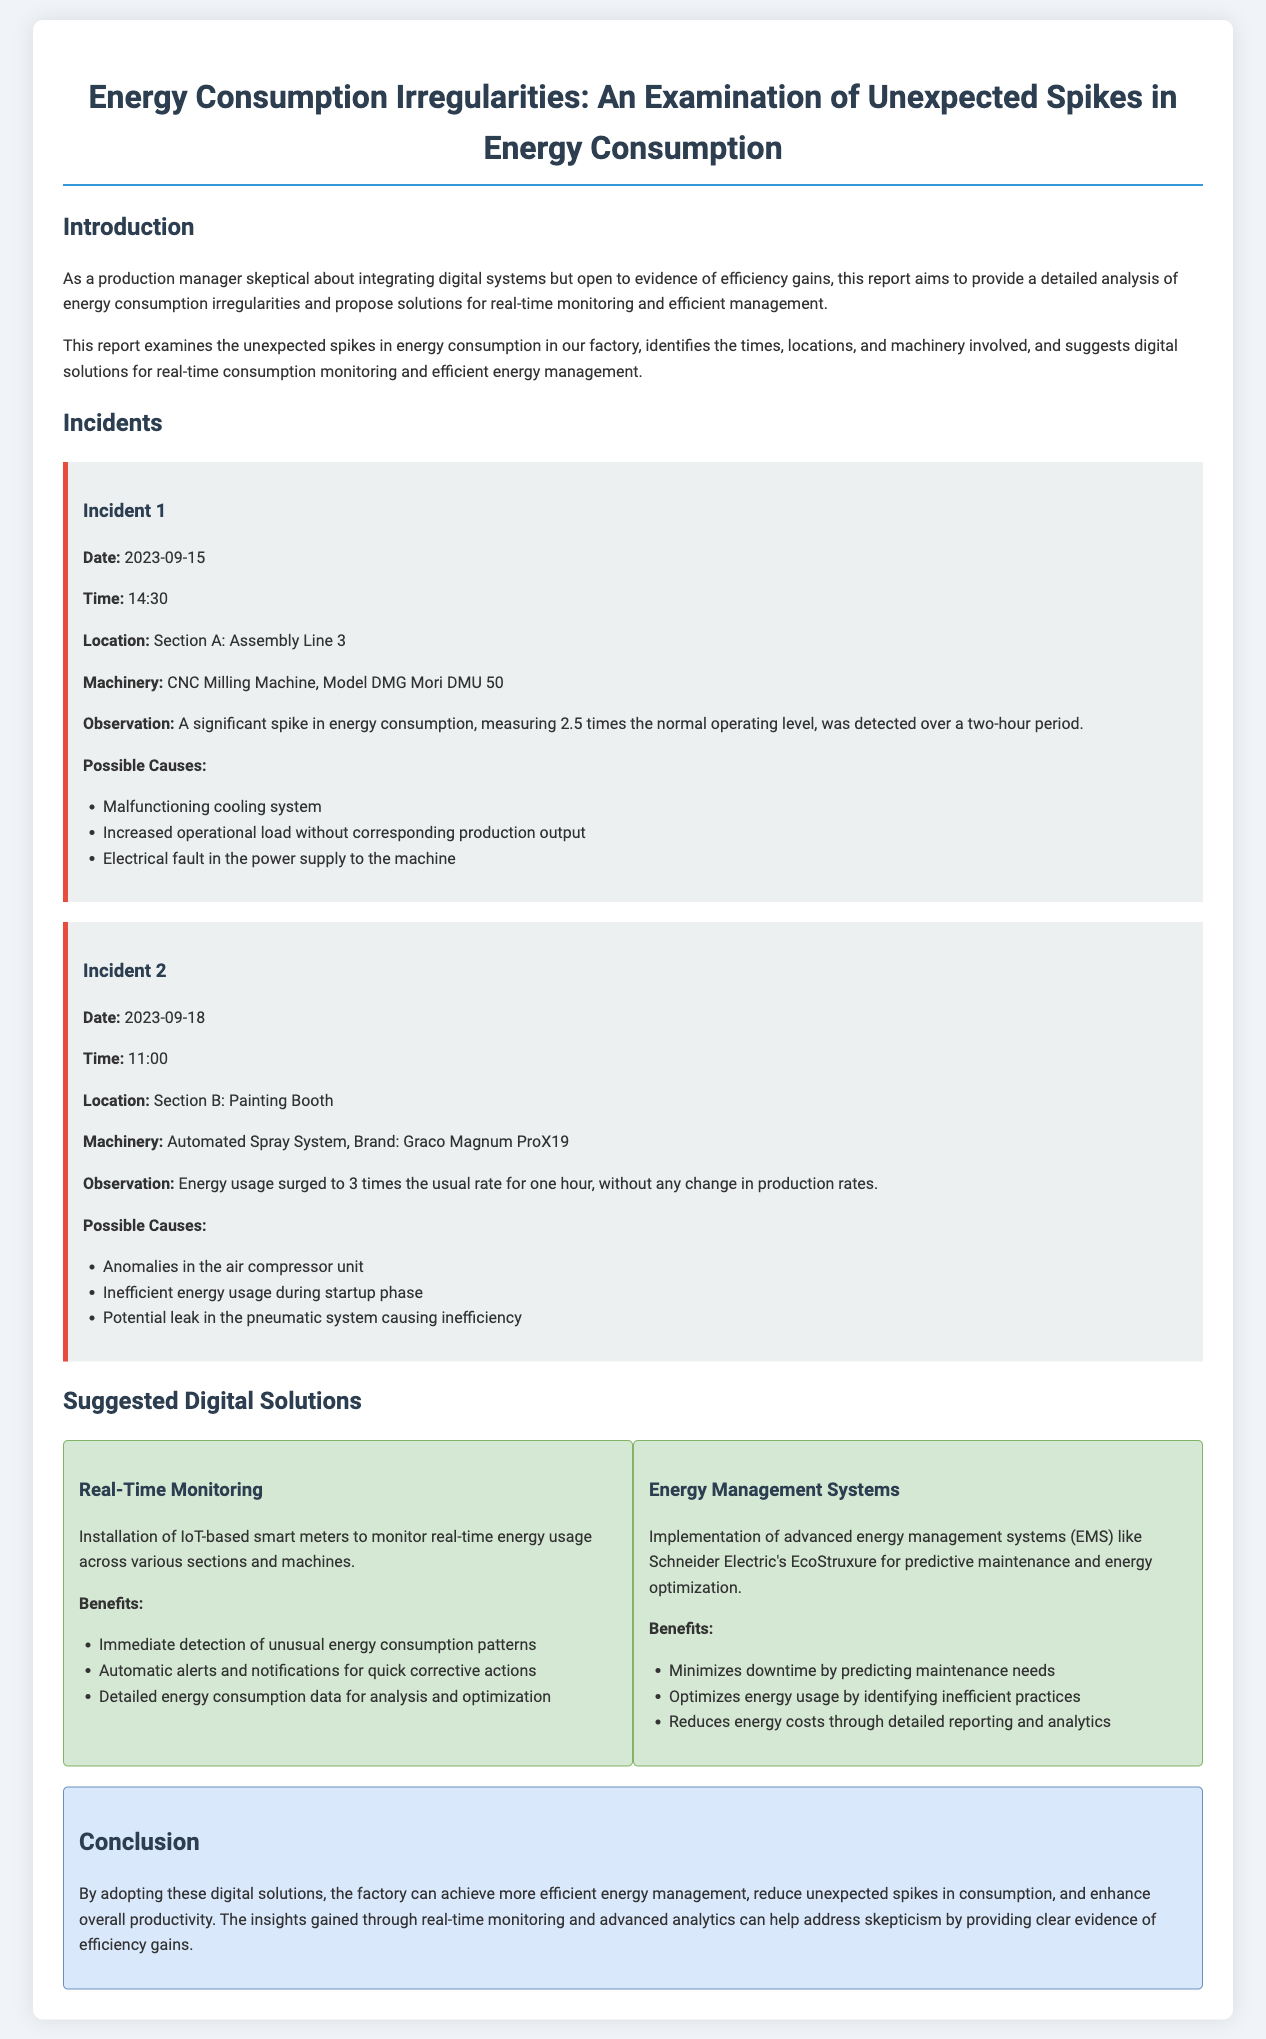what was the date of the first incident? The first incident occurred on September 15, 2023.
Answer: September 15, 2023 what was the time of the second incident? The second incident occurred at 11:00.
Answer: 11:00 which machinery was involved in Incident 1? Incident 1 involved a CNC Milling Machine, Model DMG Mori DMU 50.
Answer: CNC Milling Machine, Model DMG Mori DMU 50 how much higher was the energy consumption during Incident 2 compared to normal levels? Energy consumption during Incident 2 surged to 3 times the usual rate.
Answer: 3 times what are two possible causes for the spike in energy consumption in Incident 2? The two possible causes are anomalies in the air compressor unit and inefficient energy usage during startup phase.
Answer: Anomalies in the air compressor unit; inefficient energy usage during startup phase what is one suggested digital solution for monitoring energy consumption? Real-time monitoring using IoT-based smart meters is suggested for monitoring energy consumption.
Answer: IoT-based smart meters how can Energy Management Systems help reduce downtime? Energy Management Systems minimize downtime by predicting maintenance needs.
Answer: Predicting maintenance needs what key benefit does real-time monitoring provide? Real-time monitoring provides immediate detection of unusual energy consumption patterns.
Answer: Immediate detection of unusual energy consumption patterns 